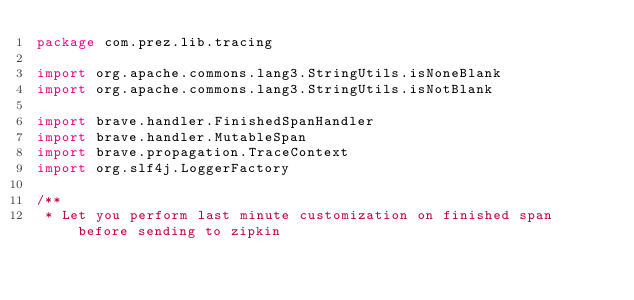<code> <loc_0><loc_0><loc_500><loc_500><_Kotlin_>package com.prez.lib.tracing

import org.apache.commons.lang3.StringUtils.isNoneBlank
import org.apache.commons.lang3.StringUtils.isNotBlank

import brave.handler.FinishedSpanHandler
import brave.handler.MutableSpan
import brave.propagation.TraceContext
import org.slf4j.LoggerFactory

/**
 * Let you perform last minute customization on finished span before sending to zipkin</code> 